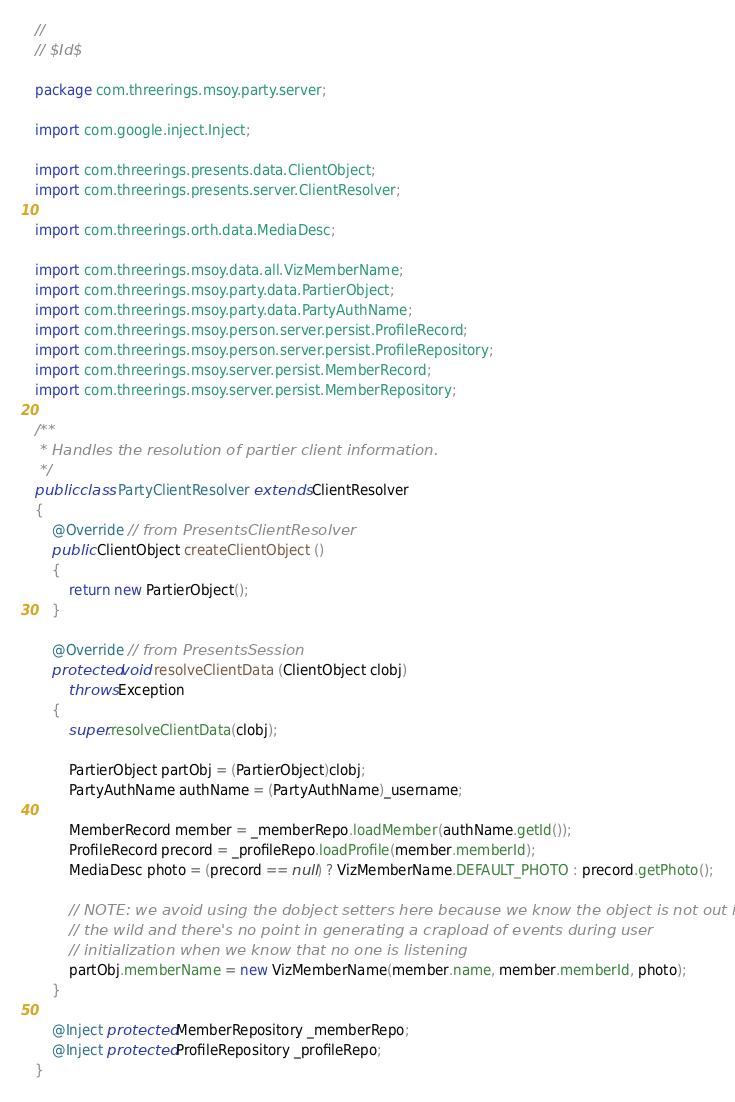Convert code to text. <code><loc_0><loc_0><loc_500><loc_500><_Java_>//
// $Id$

package com.threerings.msoy.party.server;

import com.google.inject.Inject;

import com.threerings.presents.data.ClientObject;
import com.threerings.presents.server.ClientResolver;

import com.threerings.orth.data.MediaDesc;

import com.threerings.msoy.data.all.VizMemberName;
import com.threerings.msoy.party.data.PartierObject;
import com.threerings.msoy.party.data.PartyAuthName;
import com.threerings.msoy.person.server.persist.ProfileRecord;
import com.threerings.msoy.person.server.persist.ProfileRepository;
import com.threerings.msoy.server.persist.MemberRecord;
import com.threerings.msoy.server.persist.MemberRepository;

/**
 * Handles the resolution of partier client information.
 */
public class PartyClientResolver extends ClientResolver
{
    @Override // from PresentsClientResolver
    public ClientObject createClientObject ()
    {
        return new PartierObject();
    }

    @Override // from PresentsSession
    protected void resolveClientData (ClientObject clobj)
        throws Exception
    {
        super.resolveClientData(clobj);

        PartierObject partObj = (PartierObject)clobj;
        PartyAuthName authName = (PartyAuthName)_username;

        MemberRecord member = _memberRepo.loadMember(authName.getId());
        ProfileRecord precord = _profileRepo.loadProfile(member.memberId);
        MediaDesc photo = (precord == null) ? VizMemberName.DEFAULT_PHOTO : precord.getPhoto();

        // NOTE: we avoid using the dobject setters here because we know the object is not out in
        // the wild and there's no point in generating a crapload of events during user
        // initialization when we know that no one is listening
        partObj.memberName = new VizMemberName(member.name, member.memberId, photo);
    }

    @Inject protected MemberRepository _memberRepo;
    @Inject protected ProfileRepository _profileRepo;
}
</code> 